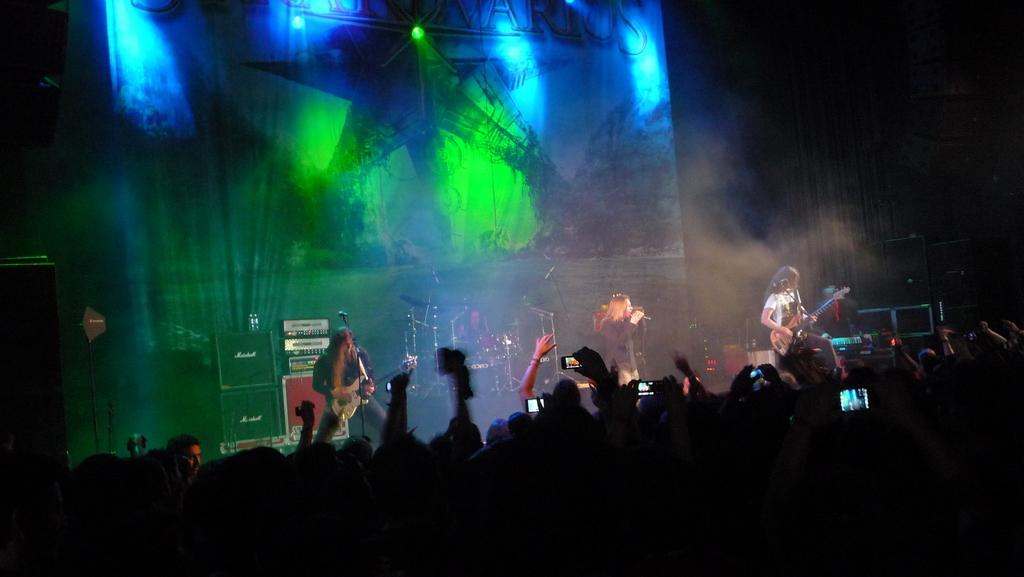Please provide a concise description of this image. This image is taken in a concert. In this image the background is dark and there is a banner with an image of a star and there is text on it. There are a few lights. At the bottom of the image there are many people and a few are holding mobile phones in their hands. In the middle of the image four people are performing on the stage and there are few musical instruments and mics on the dais and there are a few speaker boxes. 